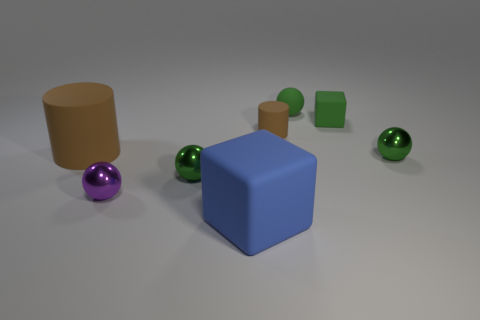What number of tiny shiny spheres are right of the small green shiny object that is left of the tiny green rubber block?
Provide a short and direct response. 1. Does the large object behind the large blue thing have the same material as the big blue block?
Give a very brief answer. Yes. What is the size of the blue cube that is to the right of the object that is to the left of the purple thing?
Keep it short and to the point. Large. What is the size of the cylinder left of the tiny shiny object that is in front of the green ball to the left of the large blue thing?
Your response must be concise. Large. There is a brown matte thing behind the big cylinder; is its shape the same as the brown object that is on the left side of the small cylinder?
Offer a terse response. Yes. How many other objects are the same color as the large cube?
Your response must be concise. 0. There is a block behind the blue thing; does it have the same size as the big brown object?
Give a very brief answer. No. Do the large thing to the left of the large rubber cube and the green ball that is on the left side of the blue object have the same material?
Provide a succinct answer. No. Are there any cyan rubber cubes of the same size as the green cube?
Your response must be concise. No. There is a thing that is on the right side of the small matte object on the right side of the small ball behind the small green rubber block; what shape is it?
Ensure brevity in your answer.  Sphere. 